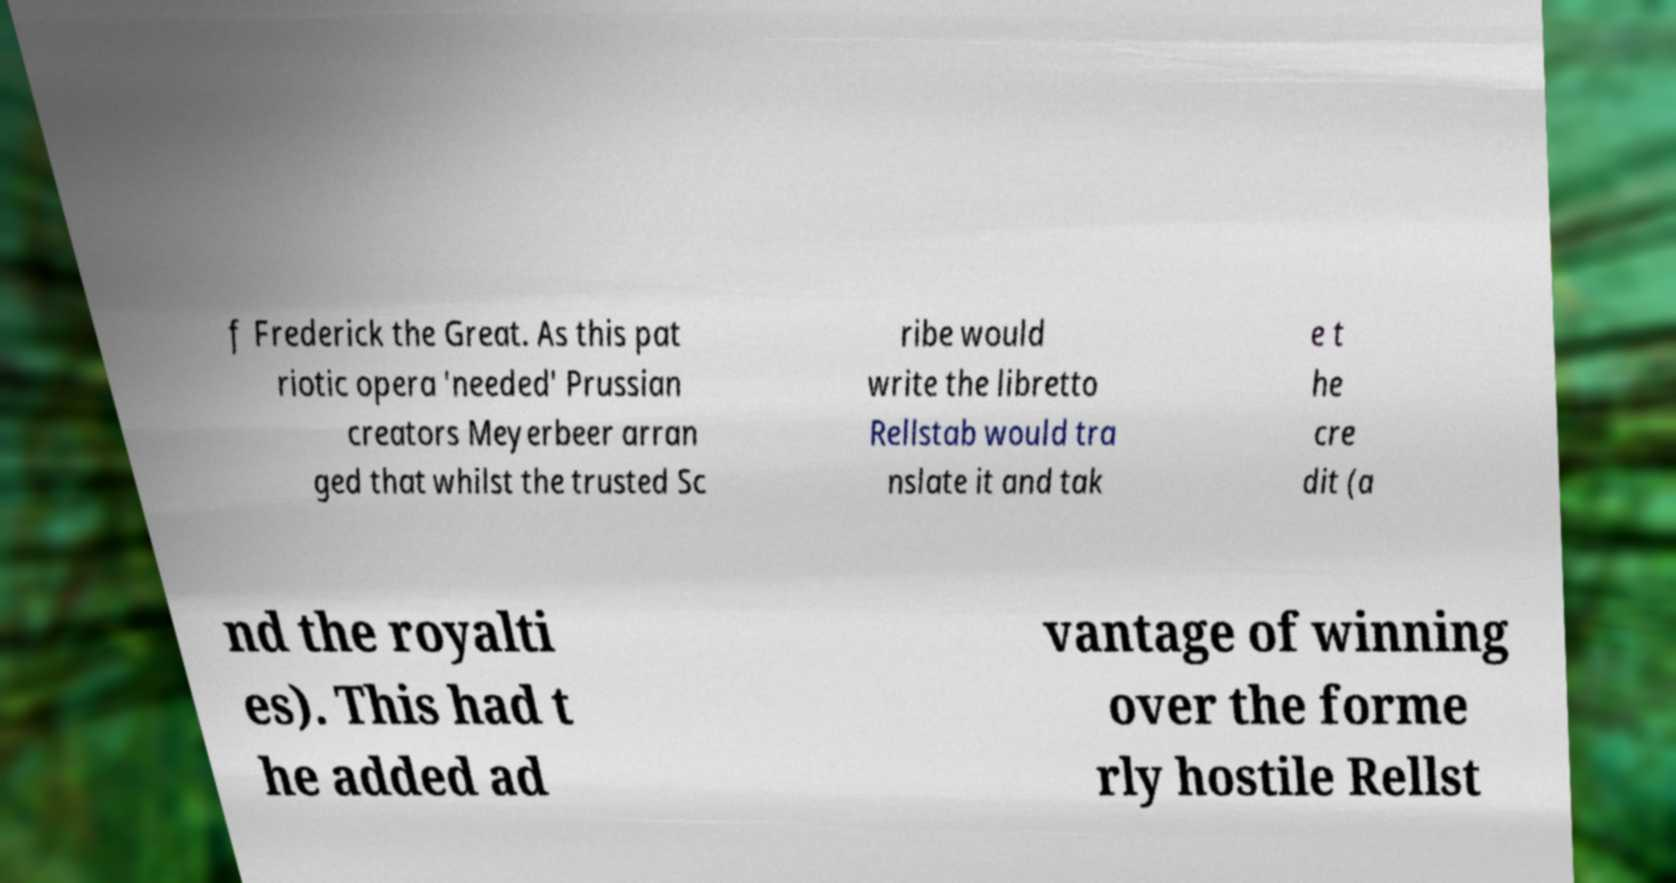Can you accurately transcribe the text from the provided image for me? f Frederick the Great. As this pat riotic opera 'needed' Prussian creators Meyerbeer arran ged that whilst the trusted Sc ribe would write the libretto Rellstab would tra nslate it and tak e t he cre dit (a nd the royalti es). This had t he added ad vantage of winning over the forme rly hostile Rellst 